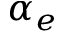Convert formula to latex. <formula><loc_0><loc_0><loc_500><loc_500>\alpha _ { e }</formula> 